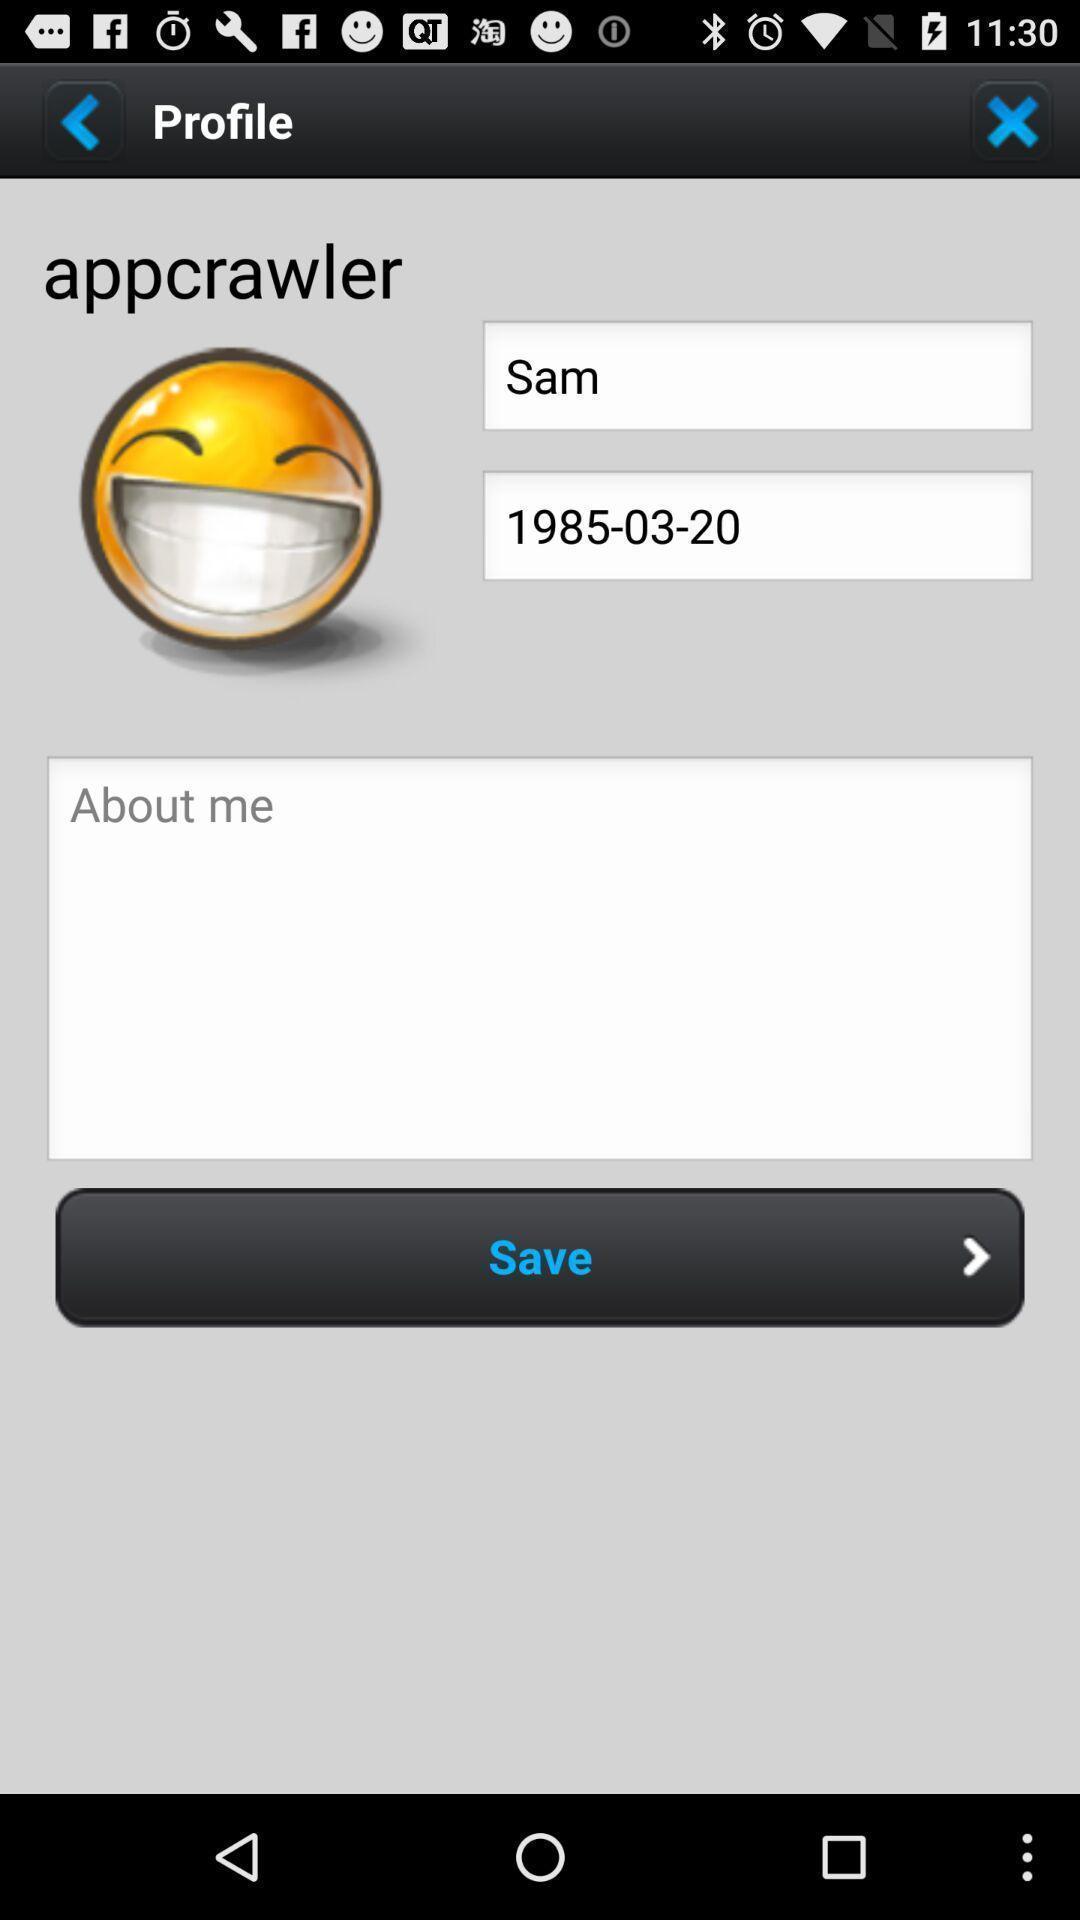What can you discern from this picture? Profile page displaying. 